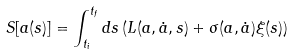Convert formula to latex. <formula><loc_0><loc_0><loc_500><loc_500>S [ a ( s ) ] = \int _ { t _ { i } } ^ { t _ { f } } d s \left ( L ( a , \dot { a } , s ) + \sigma ( a , \dot { a } ) \xi ( s ) \right )</formula> 